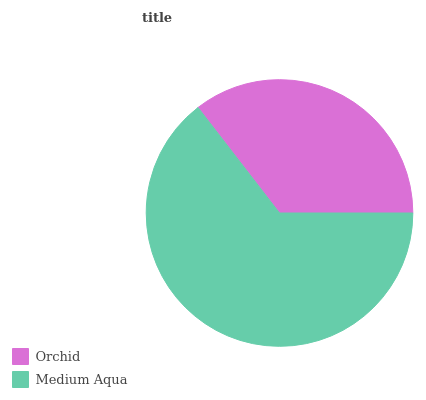Is Orchid the minimum?
Answer yes or no. Yes. Is Medium Aqua the maximum?
Answer yes or no. Yes. Is Medium Aqua the minimum?
Answer yes or no. No. Is Medium Aqua greater than Orchid?
Answer yes or no. Yes. Is Orchid less than Medium Aqua?
Answer yes or no. Yes. Is Orchid greater than Medium Aqua?
Answer yes or no. No. Is Medium Aqua less than Orchid?
Answer yes or no. No. Is Medium Aqua the high median?
Answer yes or no. Yes. Is Orchid the low median?
Answer yes or no. Yes. Is Orchid the high median?
Answer yes or no. No. Is Medium Aqua the low median?
Answer yes or no. No. 